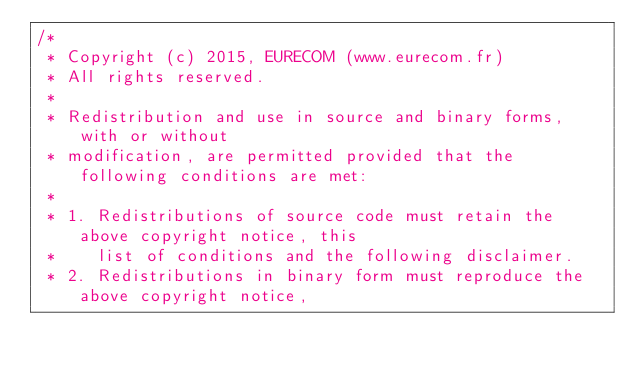<code> <loc_0><loc_0><loc_500><loc_500><_C_>/*
 * Copyright (c) 2015, EURECOM (www.eurecom.fr)
 * All rights reserved.
 *
 * Redistribution and use in source and binary forms, with or without
 * modification, are permitted provided that the following conditions are met:
 *
 * 1. Redistributions of source code must retain the above copyright notice, this
 *    list of conditions and the following disclaimer.
 * 2. Redistributions in binary form must reproduce the above copyright notice,</code> 